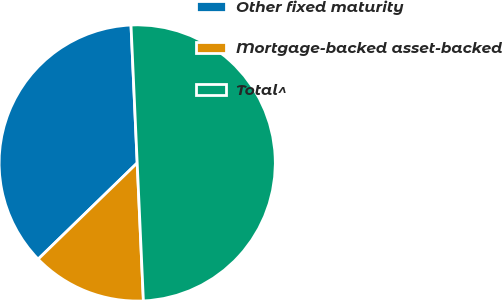<chart> <loc_0><loc_0><loc_500><loc_500><pie_chart><fcel>Other fixed maturity<fcel>Mortgage-backed asset-backed<fcel>Total^<nl><fcel>36.55%<fcel>13.45%<fcel>50.0%<nl></chart> 